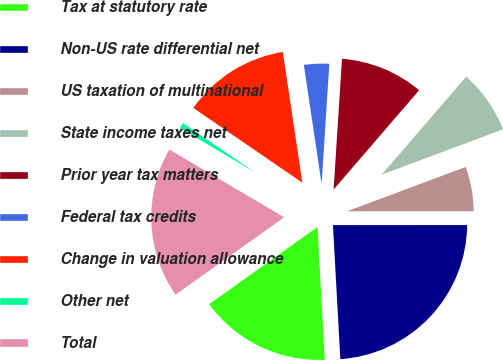Convert chart. <chart><loc_0><loc_0><loc_500><loc_500><pie_chart><fcel>Tax at statutory rate<fcel>Non-US rate differential net<fcel>US taxation of multinational<fcel>State income taxes net<fcel>Prior year tax matters<fcel>Federal tax credits<fcel>Change in valuation allowance<fcel>Other net<fcel>Total<nl><fcel>16.03%<fcel>24.13%<fcel>5.69%<fcel>7.99%<fcel>10.3%<fcel>3.38%<fcel>13.08%<fcel>1.08%<fcel>18.34%<nl></chart> 